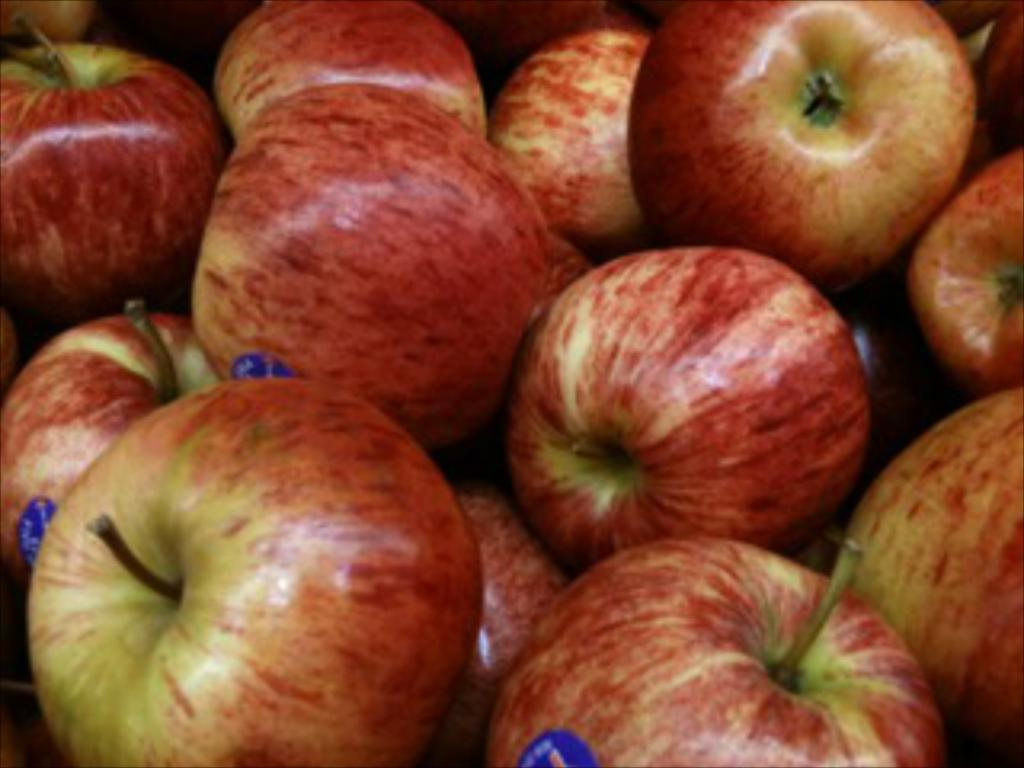What is the focus of the zoomed-in picture? The image is a zoomed-in picture of many apples in the center. What can be observed on the apples in the image? Blue color stickers are attached to the apples. Can you describe the haircut of the person standing next to the apples in the image? There is no person present in the image, only apples with blue color stickers. What force is responsible for the movement of the ocean in the image? There is no ocean present in the image; it features apples with blue color stickers. 